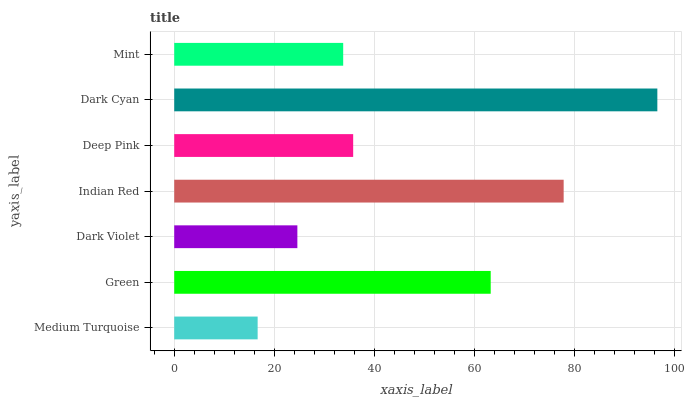Is Medium Turquoise the minimum?
Answer yes or no. Yes. Is Dark Cyan the maximum?
Answer yes or no. Yes. Is Green the minimum?
Answer yes or no. No. Is Green the maximum?
Answer yes or no. No. Is Green greater than Medium Turquoise?
Answer yes or no. Yes. Is Medium Turquoise less than Green?
Answer yes or no. Yes. Is Medium Turquoise greater than Green?
Answer yes or no. No. Is Green less than Medium Turquoise?
Answer yes or no. No. Is Deep Pink the high median?
Answer yes or no. Yes. Is Deep Pink the low median?
Answer yes or no. Yes. Is Medium Turquoise the high median?
Answer yes or no. No. Is Dark Violet the low median?
Answer yes or no. No. 